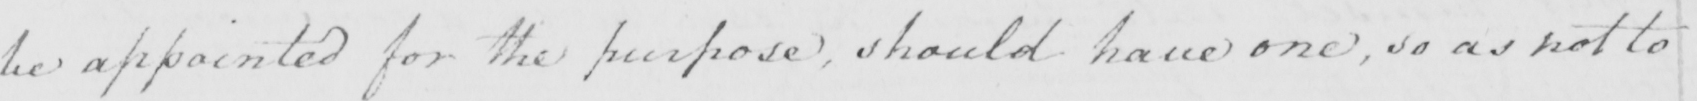Can you read and transcribe this handwriting? be appointed for the purpose  , should have one  , so as not to 